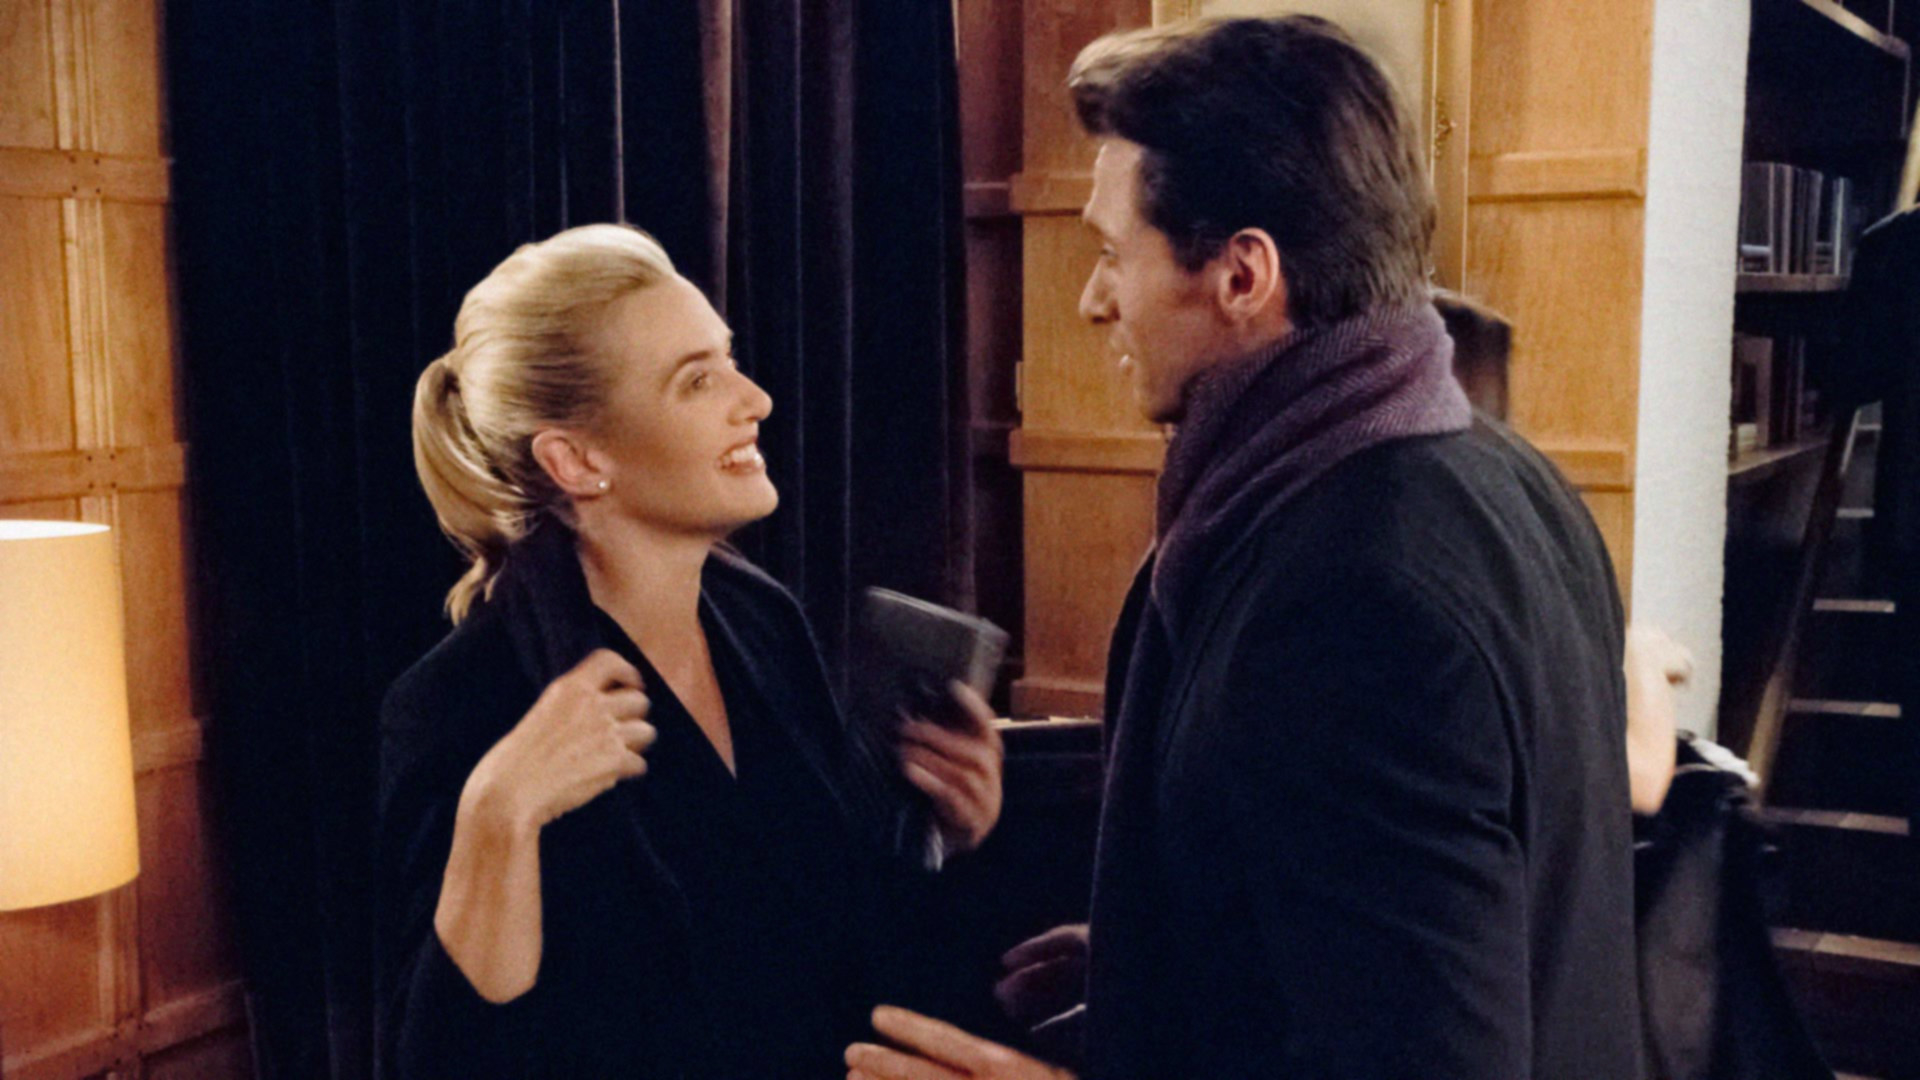Describe the body language and possible dynamic between these two characters. The body language between the two characters suggests a friendly and engaging interaction. The woman's open gestures, directed gaze, and smile indicate that she is enjoying the conversation. The man, on the other hand, seems to be sharing a point or narrating something interesting, as evidenced by the book in his hand and his attentive stance. The mutual engagement suggests a relationship built on respect, intellectual curiosity, or perhaps camaraderie. 